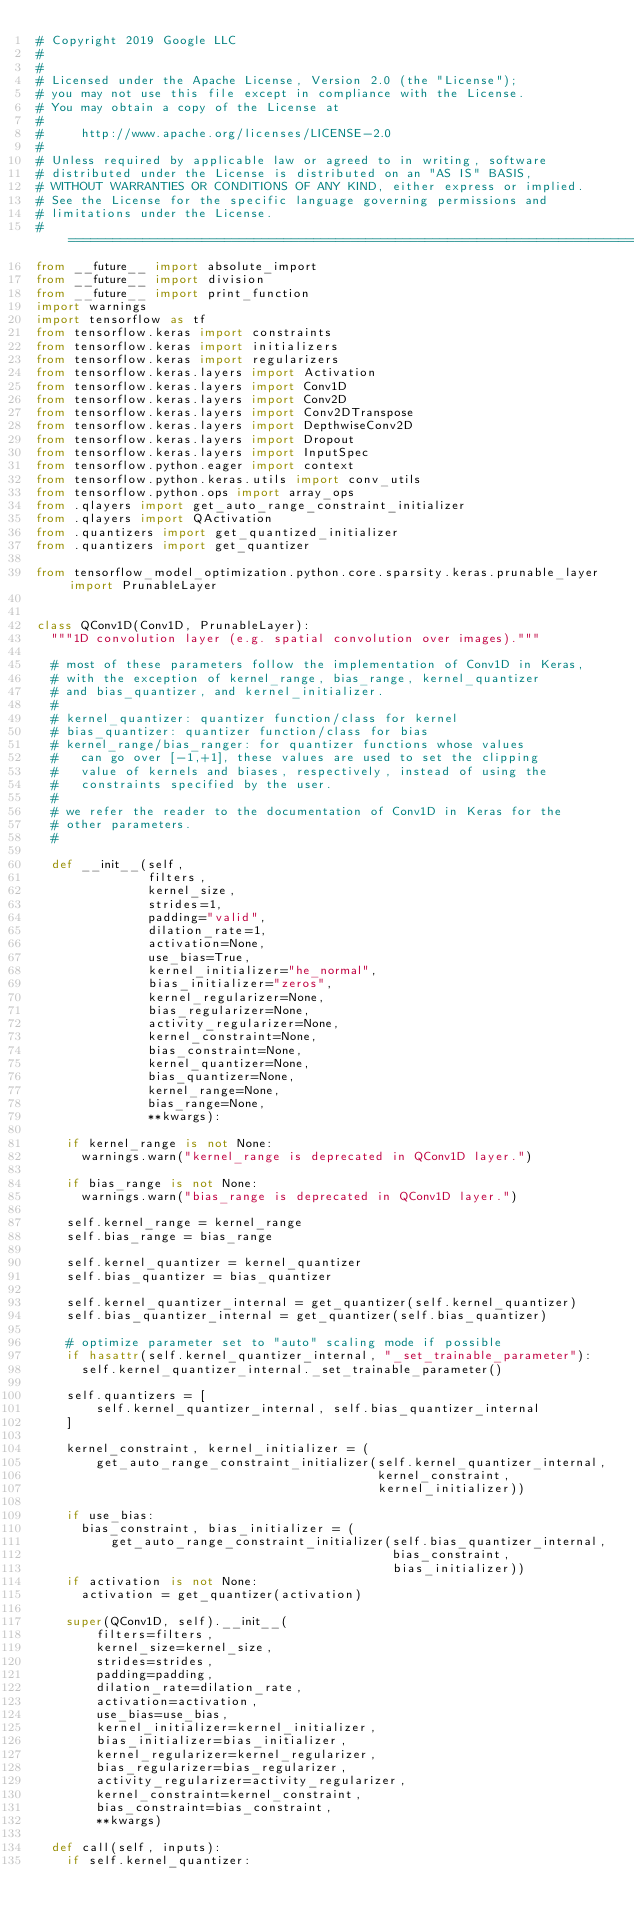Convert code to text. <code><loc_0><loc_0><loc_500><loc_500><_Python_># Copyright 2019 Google LLC
#
#
# Licensed under the Apache License, Version 2.0 (the "License");
# you may not use this file except in compliance with the License.
# You may obtain a copy of the License at
#
#     http://www.apache.org/licenses/LICENSE-2.0
#
# Unless required by applicable law or agreed to in writing, software
# distributed under the License is distributed on an "AS IS" BASIS,
# WITHOUT WARRANTIES OR CONDITIONS OF ANY KIND, either express or implied.
# See the License for the specific language governing permissions and
# limitations under the License.
# ==============================================================================
from __future__ import absolute_import
from __future__ import division
from __future__ import print_function
import warnings
import tensorflow as tf
from tensorflow.keras import constraints
from tensorflow.keras import initializers
from tensorflow.keras import regularizers
from tensorflow.keras.layers import Activation
from tensorflow.keras.layers import Conv1D
from tensorflow.keras.layers import Conv2D
from tensorflow.keras.layers import Conv2DTranspose
from tensorflow.keras.layers import DepthwiseConv2D
from tensorflow.keras.layers import Dropout
from tensorflow.keras.layers import InputSpec
from tensorflow.python.eager import context
from tensorflow.python.keras.utils import conv_utils
from tensorflow.python.ops import array_ops
from .qlayers import get_auto_range_constraint_initializer
from .qlayers import QActivation
from .quantizers import get_quantized_initializer
from .quantizers import get_quantizer

from tensorflow_model_optimization.python.core.sparsity.keras.prunable_layer import PrunableLayer


class QConv1D(Conv1D, PrunableLayer):
  """1D convolution layer (e.g. spatial convolution over images)."""

  # most of these parameters follow the implementation of Conv1D in Keras,
  # with the exception of kernel_range, bias_range, kernel_quantizer
  # and bias_quantizer, and kernel_initializer.
  #
  # kernel_quantizer: quantizer function/class for kernel
  # bias_quantizer: quantizer function/class for bias
  # kernel_range/bias_ranger: for quantizer functions whose values
  #   can go over [-1,+1], these values are used to set the clipping
  #   value of kernels and biases, respectively, instead of using the
  #   constraints specified by the user.
  #
  # we refer the reader to the documentation of Conv1D in Keras for the
  # other parameters.
  #

  def __init__(self,
               filters,
               kernel_size,
               strides=1,
               padding="valid",
               dilation_rate=1,
               activation=None,
               use_bias=True,
               kernel_initializer="he_normal",
               bias_initializer="zeros",
               kernel_regularizer=None,
               bias_regularizer=None,
               activity_regularizer=None,
               kernel_constraint=None,
               bias_constraint=None,
               kernel_quantizer=None,
               bias_quantizer=None,
               kernel_range=None,
               bias_range=None,
               **kwargs):

    if kernel_range is not None:
      warnings.warn("kernel_range is deprecated in QConv1D layer.")

    if bias_range is not None:
      warnings.warn("bias_range is deprecated in QConv1D layer.")

    self.kernel_range = kernel_range
    self.bias_range = bias_range

    self.kernel_quantizer = kernel_quantizer
    self.bias_quantizer = bias_quantizer

    self.kernel_quantizer_internal = get_quantizer(self.kernel_quantizer)
    self.bias_quantizer_internal = get_quantizer(self.bias_quantizer)

    # optimize parameter set to "auto" scaling mode if possible
    if hasattr(self.kernel_quantizer_internal, "_set_trainable_parameter"):
      self.kernel_quantizer_internal._set_trainable_parameter()

    self.quantizers = [
        self.kernel_quantizer_internal, self.bias_quantizer_internal
    ]

    kernel_constraint, kernel_initializer = (
        get_auto_range_constraint_initializer(self.kernel_quantizer_internal,
                                              kernel_constraint,
                                              kernel_initializer))

    if use_bias:
      bias_constraint, bias_initializer = (
          get_auto_range_constraint_initializer(self.bias_quantizer_internal,
                                                bias_constraint,
                                                bias_initializer))
    if activation is not None:
      activation = get_quantizer(activation)

    super(QConv1D, self).__init__(
        filters=filters,
        kernel_size=kernel_size,
        strides=strides,
        padding=padding,
        dilation_rate=dilation_rate,
        activation=activation,
        use_bias=use_bias,
        kernel_initializer=kernel_initializer,
        bias_initializer=bias_initializer,
        kernel_regularizer=kernel_regularizer,
        bias_regularizer=bias_regularizer,
        activity_regularizer=activity_regularizer,
        kernel_constraint=kernel_constraint,
        bias_constraint=bias_constraint,
        **kwargs)

  def call(self, inputs):
    if self.kernel_quantizer:</code> 